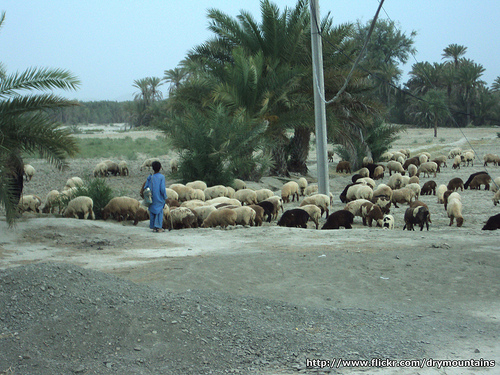<image>
Is there a pole in front of the sheep? No. The pole is not in front of the sheep. The spatial positioning shows a different relationship between these objects. 